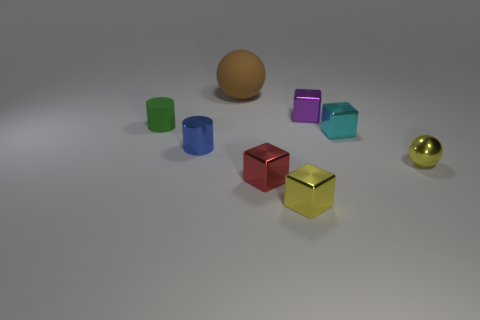Can you tell me the total number of objects in the image? Certainly! There are a total of seven objects in the image.  Are there more metallic objects or matte objects in this setup? In the image, there appears to be a larger number of matte objects when compared to metallic ones. 